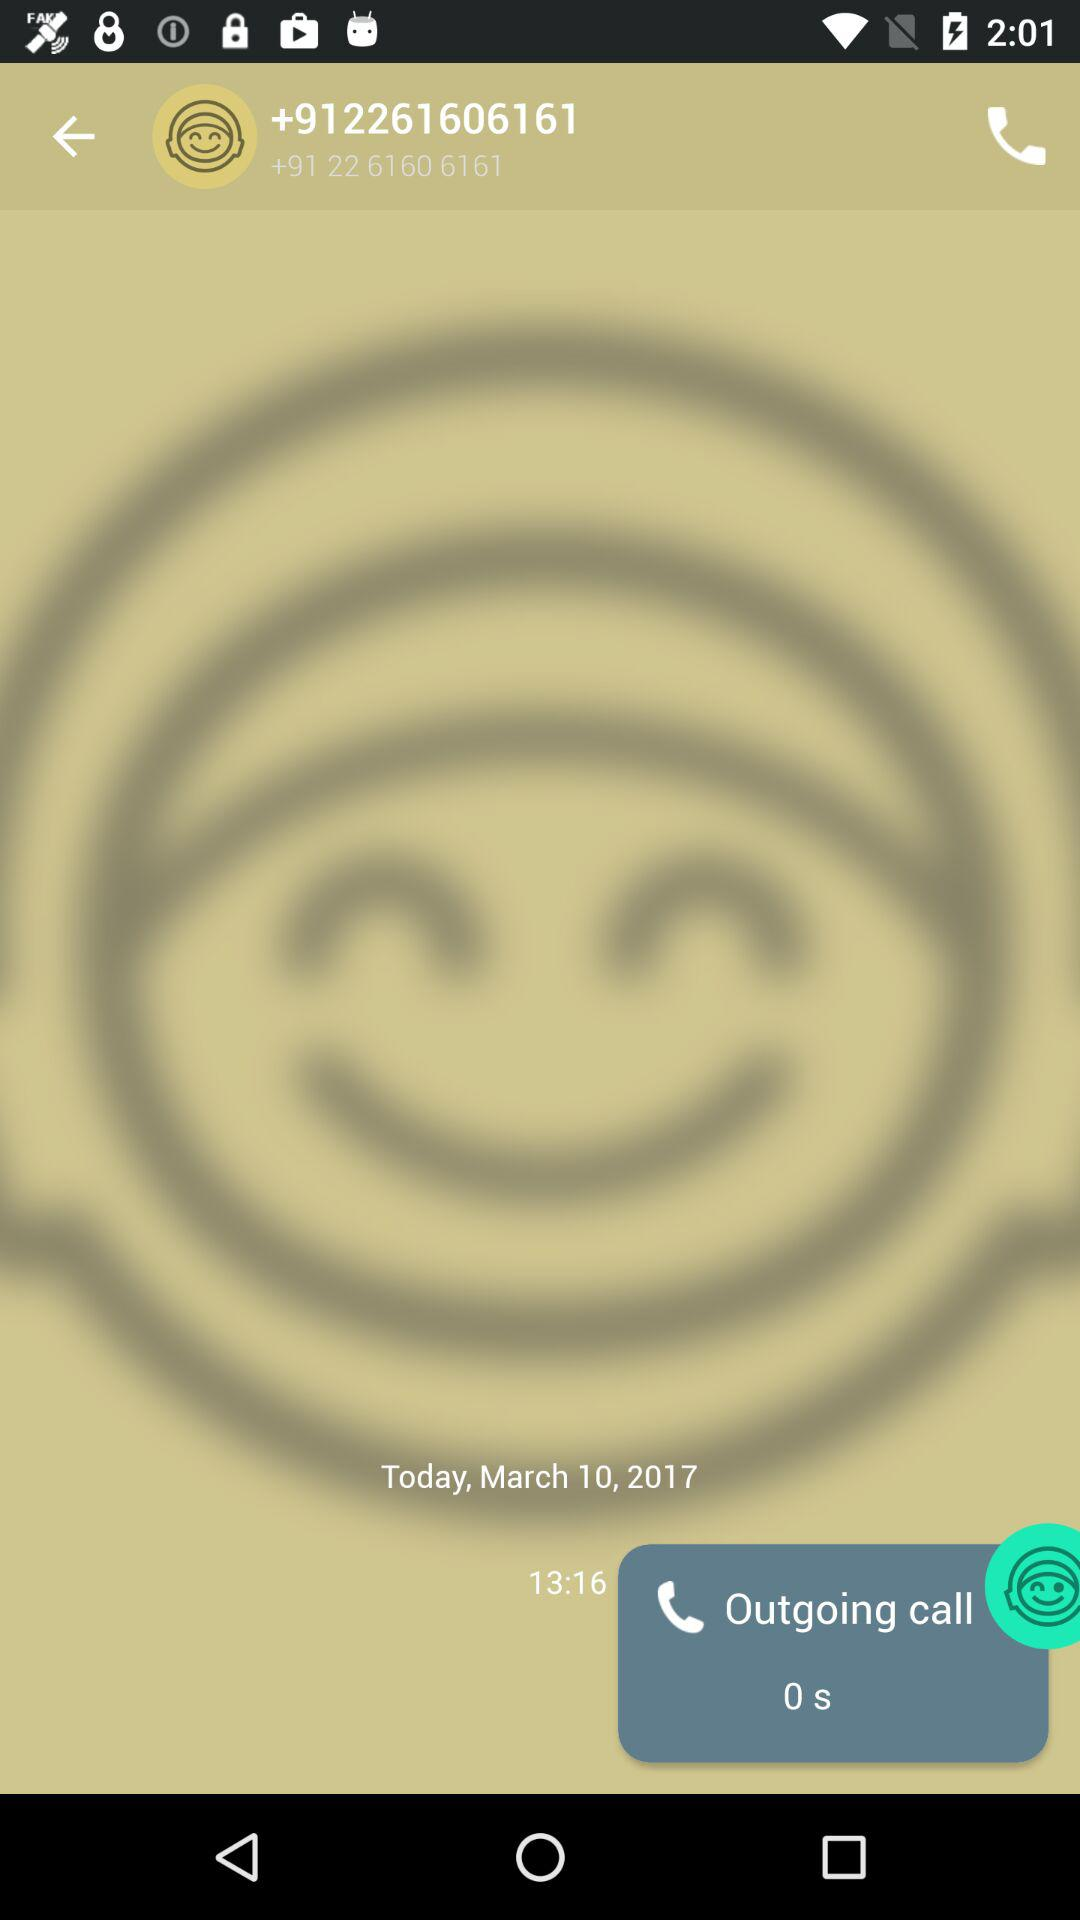What is the phone number? The phone number is +91 22 6160 6161. 